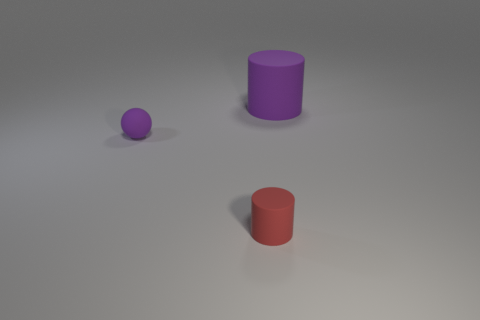What shape is the object that is the same color as the large cylinder?
Your answer should be compact. Sphere. How many matte things are tiny purple objects or purple cylinders?
Your response must be concise. 2. What color is the cylinder that is behind the tiny red cylinder to the right of the tiny rubber object that is on the left side of the small cylinder?
Keep it short and to the point. Purple. The big rubber object that is the same shape as the tiny red matte thing is what color?
Ensure brevity in your answer.  Purple. Are there any other things that are the same color as the small matte cylinder?
Provide a short and direct response. No. What number of other things are there of the same material as the red object
Give a very brief answer. 2. What size is the purple cylinder?
Your answer should be compact. Large. Are there any other big things that have the same shape as the red matte thing?
Your answer should be compact. Yes. How many things are large blue matte objects or matte objects that are on the right side of the tiny sphere?
Give a very brief answer. 2. There is a cylinder that is behind the tiny purple matte thing; what color is it?
Offer a very short reply. Purple. 